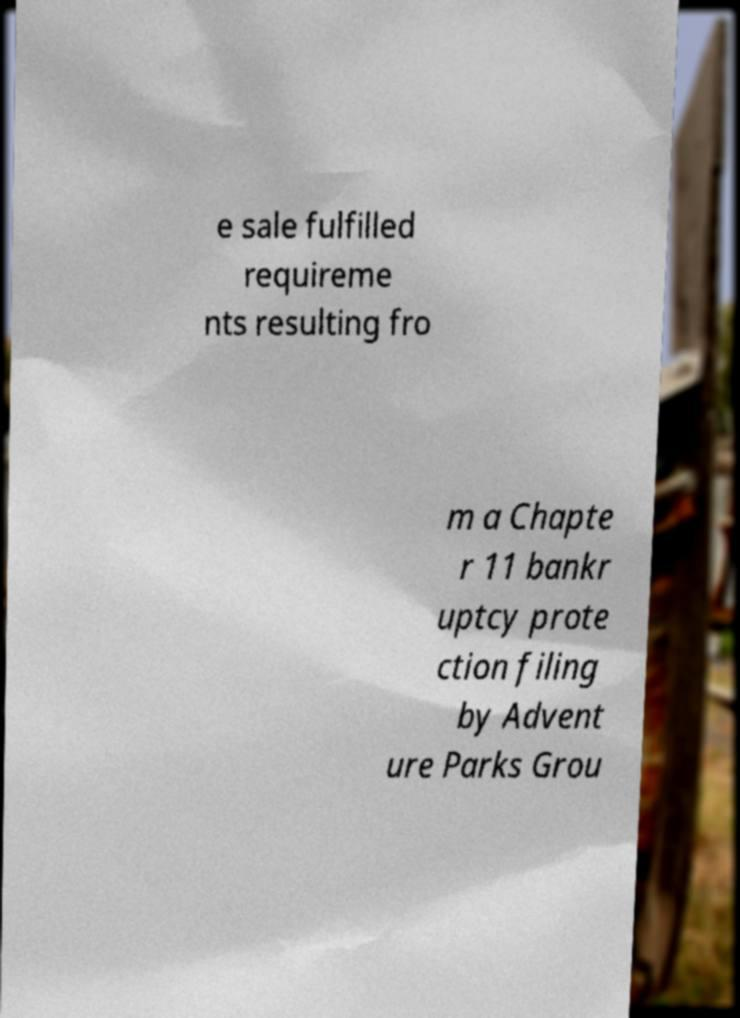Please identify and transcribe the text found in this image. e sale fulfilled requireme nts resulting fro m a Chapte r 11 bankr uptcy prote ction filing by Advent ure Parks Grou 